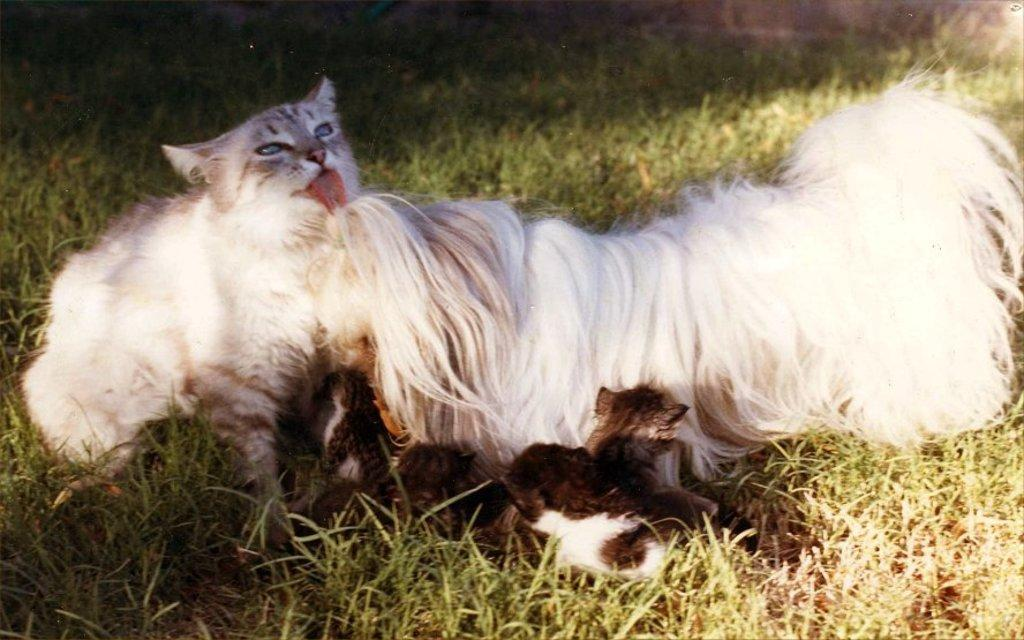What type of animals are present in the image? There is a cat, a dog, and kittens in the image. Where are the animals located in the image? The cat, dog, and kittens are on the ground. How many kittens are there in the image? There are kittens in the image, but the exact number is not specified. What type of tub can be seen in the image? There is no tub present in the image. What story is the cat telling the dog in the image? There is no indication of a story being told in the image; the animals are simply present on the ground. 